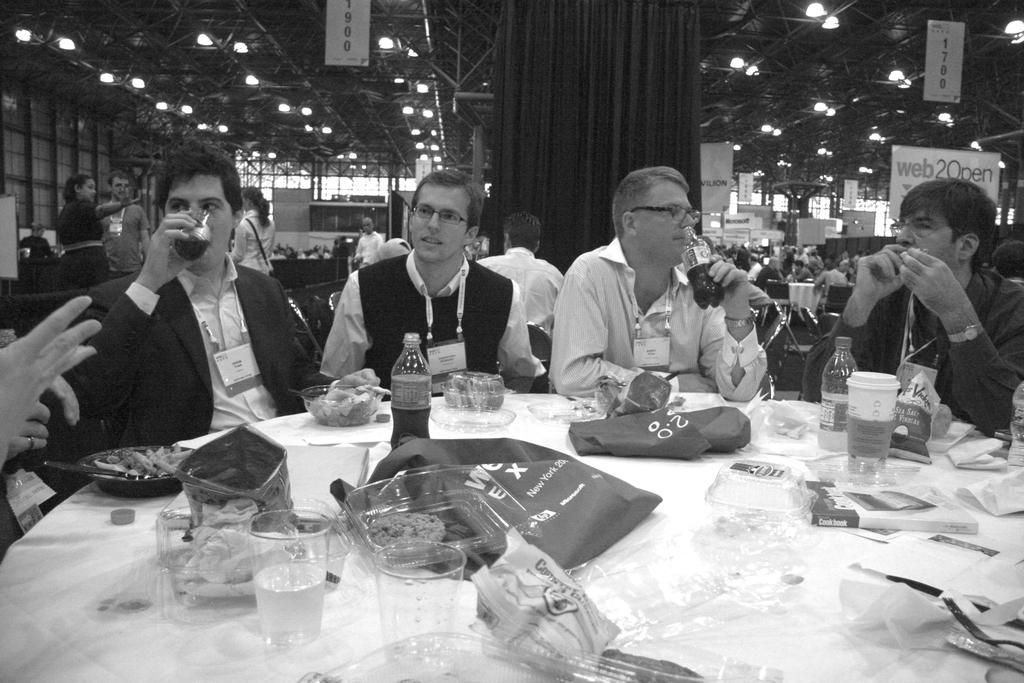Could you give a brief overview of what you see in this image? In this picture we can see a group of people some are sitting on chairs and drinking with glass and bottles and some are standing and in front of them there is table and on table we can see glasses. boxes, bag, cloth, bottles, bowl some dishes in it and in background we can see curtains, lights, banners, wall. 